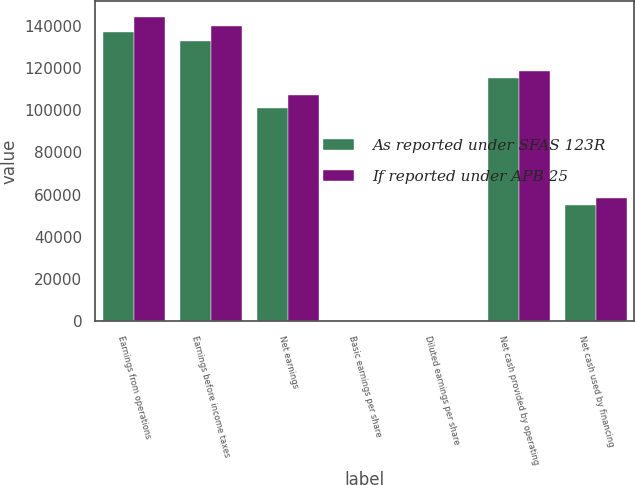Convert chart. <chart><loc_0><loc_0><loc_500><loc_500><stacked_bar_chart><ecel><fcel>Earnings from operations<fcel>Earnings before income taxes<fcel>Net earnings<fcel>Basic earnings per share<fcel>Diluted earnings per share<fcel>Net cash provided by operating<fcel>Net cash used by financing<nl><fcel>As reported under SFAS 123R<fcel>136955<fcel>132611<fcel>100896<fcel>1.49<fcel>1.32<fcel>115155<fcel>55059<nl><fcel>If reported under APB 25<fcel>144361<fcel>140017<fcel>107178<fcel>1.58<fcel>1.4<fcel>118706<fcel>58610<nl></chart> 